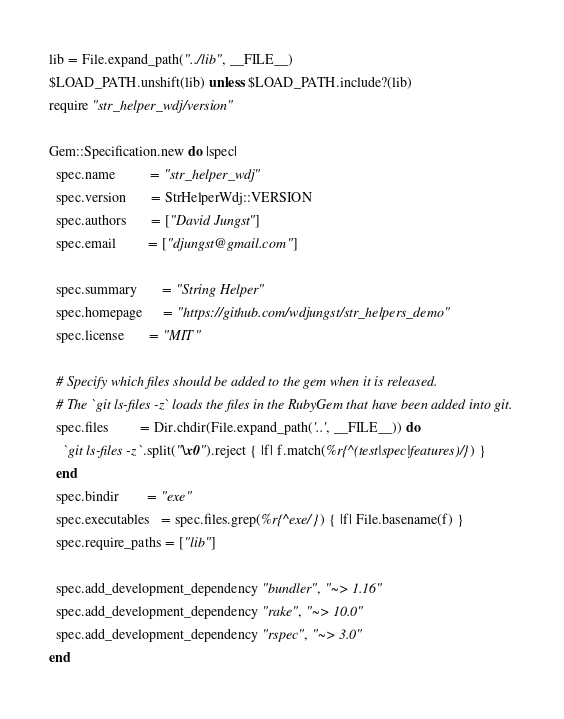Convert code to text. <code><loc_0><loc_0><loc_500><loc_500><_Ruby_>
lib = File.expand_path("../lib", __FILE__)
$LOAD_PATH.unshift(lib) unless $LOAD_PATH.include?(lib)
require "str_helper_wdj/version"

Gem::Specification.new do |spec|
  spec.name          = "str_helper_wdj"
  spec.version       = StrHelperWdj::VERSION
  spec.authors       = ["David Jungst"]
  spec.email         = ["djungst@gmail.com"]

  spec.summary       = "String Helper"
  spec.homepage      = "https://github.com/wdjungst/str_helpers_demo"
  spec.license       = "MIT"

  # Specify which files should be added to the gem when it is released.
  # The `git ls-files -z` loads the files in the RubyGem that have been added into git.
  spec.files         = Dir.chdir(File.expand_path('..', __FILE__)) do
    `git ls-files -z`.split("\x0").reject { |f| f.match(%r{^(test|spec|features)/}) }
  end
  spec.bindir        = "exe"
  spec.executables   = spec.files.grep(%r{^exe/}) { |f| File.basename(f) }
  spec.require_paths = ["lib"]

  spec.add_development_dependency "bundler", "~> 1.16"
  spec.add_development_dependency "rake", "~> 10.0"
  spec.add_development_dependency "rspec", "~> 3.0"
end
</code> 